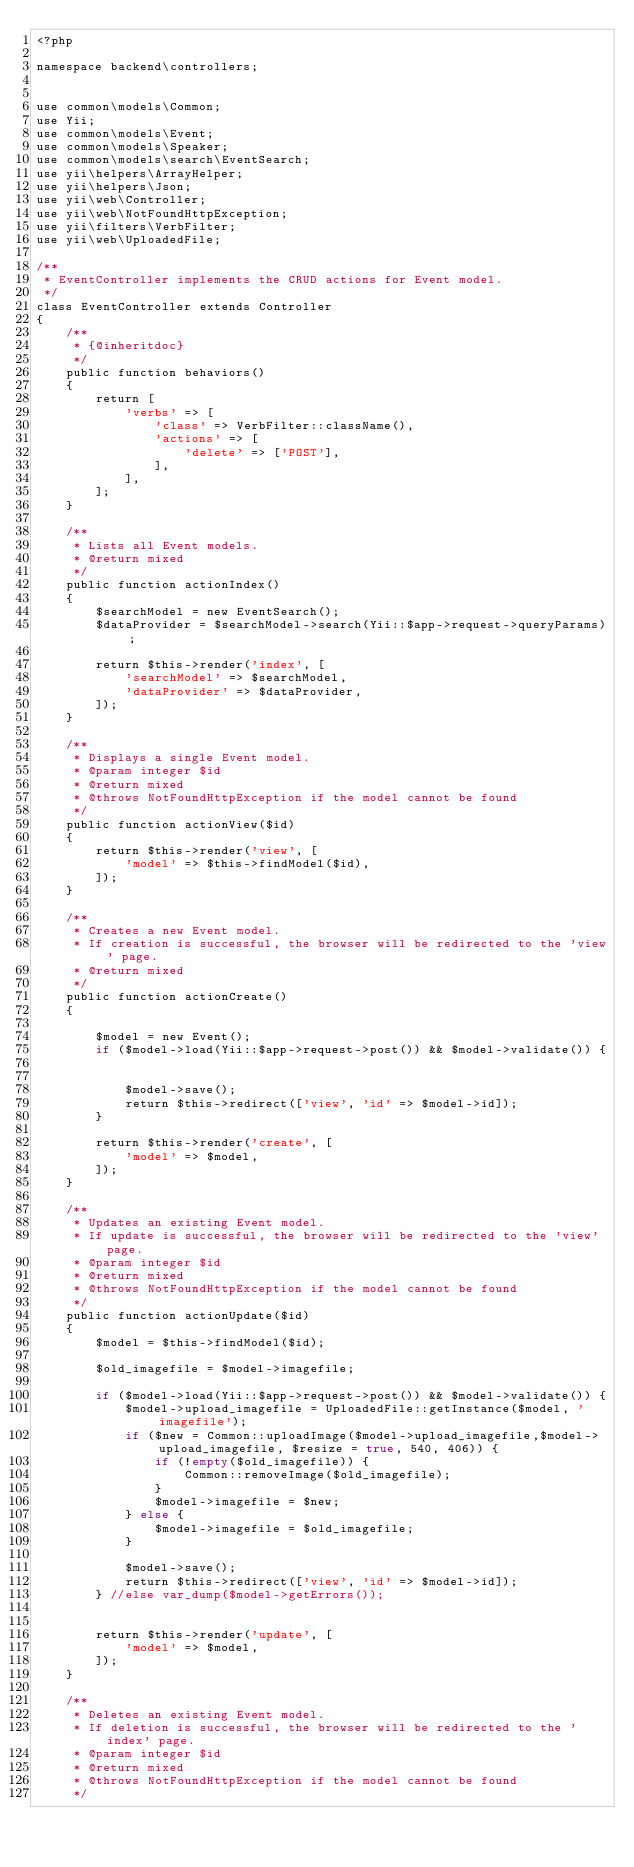Convert code to text. <code><loc_0><loc_0><loc_500><loc_500><_PHP_><?php

namespace backend\controllers;


use common\models\Common;
use Yii;
use common\models\Event;
use common\models\Speaker;
use common\models\search\EventSearch;
use yii\helpers\ArrayHelper;
use yii\helpers\Json;
use yii\web\Controller;
use yii\web\NotFoundHttpException;
use yii\filters\VerbFilter;
use yii\web\UploadedFile;

/**
 * EventController implements the CRUD actions for Event model.
 */
class EventController extends Controller
{
    /**
     * {@inheritdoc}
     */
    public function behaviors()
    {
        return [
            'verbs' => [
                'class' => VerbFilter::className(),
                'actions' => [
                    'delete' => ['POST'],
                ],
            ],
        ];
    }

    /**
     * Lists all Event models.
     * @return mixed
     */
    public function actionIndex()
    {
        $searchModel = new EventSearch();
        $dataProvider = $searchModel->search(Yii::$app->request->queryParams);

        return $this->render('index', [
            'searchModel' => $searchModel,
            'dataProvider' => $dataProvider,
        ]);
    }

    /**
     * Displays a single Event model.
     * @param integer $id
     * @return mixed
     * @throws NotFoundHttpException if the model cannot be found
     */
    public function actionView($id)
    {
        return $this->render('view', [
            'model' => $this->findModel($id),
        ]);
    }

    /**
     * Creates a new Event model.
     * If creation is successful, the browser will be redirected to the 'view' page.
     * @return mixed
     */
    public function actionCreate()
    {

        $model = new Event();
        if ($model->load(Yii::$app->request->post()) && $model->validate()) {


            $model->save();
            return $this->redirect(['view', 'id' => $model->id]);
        }

        return $this->render('create', [
            'model' => $model,
        ]);
    }

    /**
     * Updates an existing Event model.
     * If update is successful, the browser will be redirected to the 'view' page.
     * @param integer $id
     * @return mixed
     * @throws NotFoundHttpException if the model cannot be found
     */
    public function actionUpdate($id)
    {
        $model = $this->findModel($id);

        $old_imagefile = $model->imagefile;

        if ($model->load(Yii::$app->request->post()) && $model->validate()) {
            $model->upload_imagefile = UploadedFile::getInstance($model, 'imagefile');
            if ($new = Common::uploadImage($model->upload_imagefile,$model->upload_imagefile, $resize = true, 540, 406)) {
                if (!empty($old_imagefile)) {
                    Common::removeImage($old_imagefile);
                }
                $model->imagefile = $new;
            } else {
                $model->imagefile = $old_imagefile;
            }

            $model->save();
            return $this->redirect(['view', 'id' => $model->id]);
        } //else var_dump($model->getErrors());


        return $this->render('update', [
            'model' => $model,
        ]);
    }

    /**
     * Deletes an existing Event model.
     * If deletion is successful, the browser will be redirected to the 'index' page.
     * @param integer $id
     * @return mixed
     * @throws NotFoundHttpException if the model cannot be found
     */</code> 